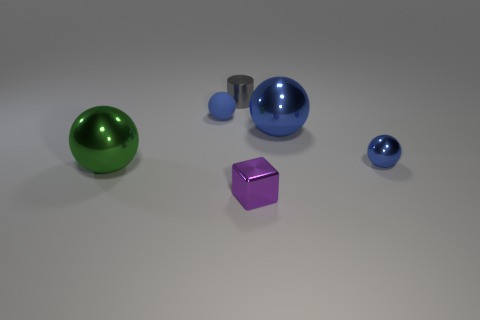There is a blue object behind the big blue ball; is its size the same as the thing that is on the left side of the tiny rubber object?
Your response must be concise. No. How many other objects are there of the same shape as the blue rubber thing?
Keep it short and to the point. 3. What is the big sphere to the left of the blue object left of the gray cylinder made of?
Your answer should be compact. Metal. How many shiny things are blue spheres or tiny cylinders?
Ensure brevity in your answer.  3. Is there any other thing that is made of the same material as the gray object?
Make the answer very short. Yes. There is a blue thing that is behind the big blue metallic ball; is there a large metallic object that is to the left of it?
Your answer should be very brief. Yes. How many objects are either small things that are on the left side of the tiny metal cube or things that are behind the big green ball?
Provide a short and direct response. 4. Are there any other things of the same color as the small metallic cylinder?
Offer a very short reply. No. What is the color of the small thing in front of the metallic sphere that is on the left side of the shiny object behind the tiny rubber sphere?
Your answer should be very brief. Purple. What size is the shiny ball left of the blue thing that is to the left of the small gray metal cylinder?
Provide a short and direct response. Large. 